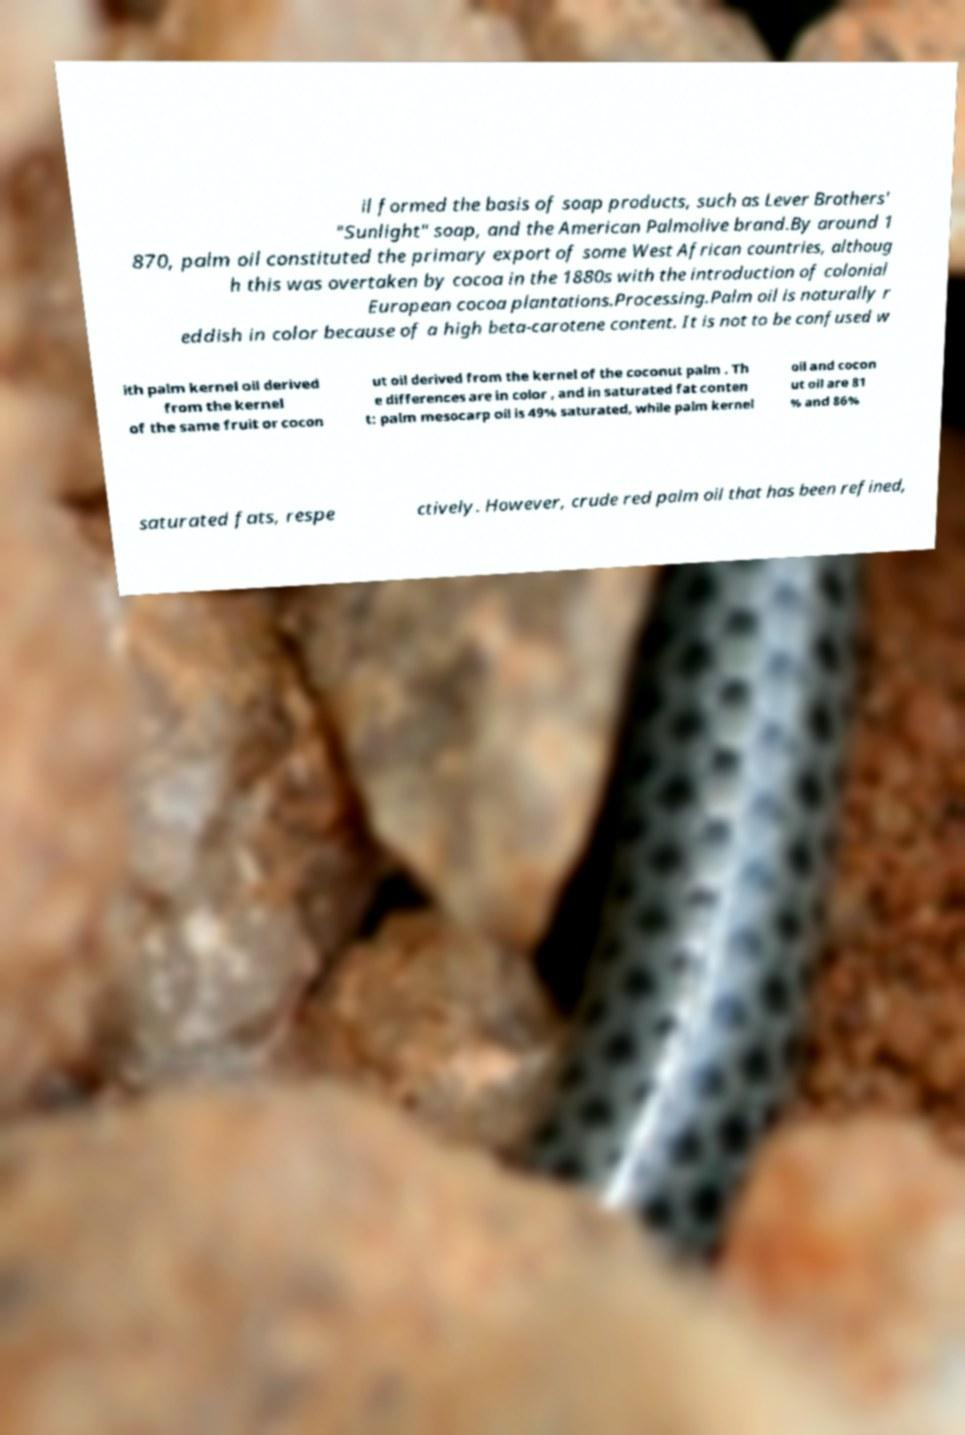Can you read and provide the text displayed in the image?This photo seems to have some interesting text. Can you extract and type it out for me? il formed the basis of soap products, such as Lever Brothers' "Sunlight" soap, and the American Palmolive brand.By around 1 870, palm oil constituted the primary export of some West African countries, althoug h this was overtaken by cocoa in the 1880s with the introduction of colonial European cocoa plantations.Processing.Palm oil is naturally r eddish in color because of a high beta-carotene content. It is not to be confused w ith palm kernel oil derived from the kernel of the same fruit or cocon ut oil derived from the kernel of the coconut palm . Th e differences are in color , and in saturated fat conten t: palm mesocarp oil is 49% saturated, while palm kernel oil and cocon ut oil are 81 % and 86% saturated fats, respe ctively. However, crude red palm oil that has been refined, 